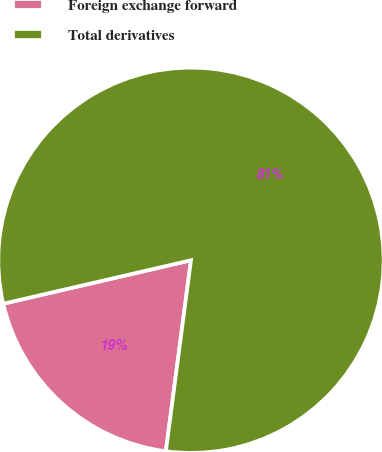Convert chart to OTSL. <chart><loc_0><loc_0><loc_500><loc_500><pie_chart><fcel>Foreign exchange forward<fcel>Total derivatives<nl><fcel>19.3%<fcel>80.7%<nl></chart> 